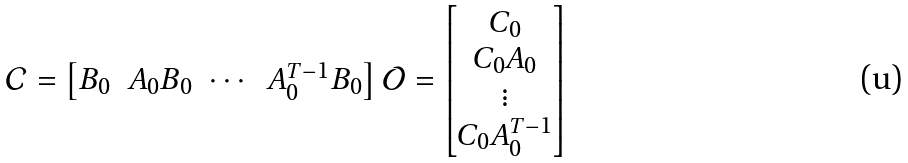Convert formula to latex. <formula><loc_0><loc_0><loc_500><loc_500>\mathcal { C } = \begin{bmatrix} B _ { 0 } & A _ { 0 } B _ { 0 } & \cdots & A _ { 0 } ^ { T - 1 } B _ { 0 } \end{bmatrix} \mathcal { O } = \begin{bmatrix} C _ { 0 } \\ C _ { 0 } A _ { 0 } \\ \vdots \\ C _ { 0 } A _ { 0 } ^ { T - 1 } \end{bmatrix}</formula> 